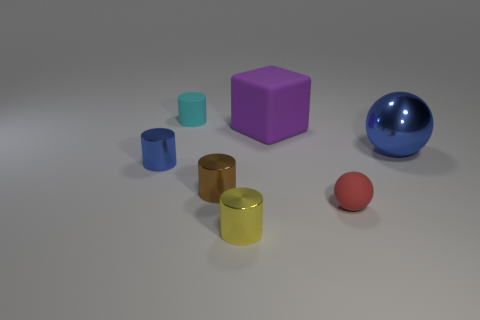Do the blue sphere to the right of the brown cylinder and the small cylinder behind the big rubber cube have the same material?
Your response must be concise. No. There is a shiny ball; is its color the same as the large thing that is left of the metal sphere?
Your answer should be very brief. No. There is a object that is both on the right side of the purple object and in front of the blue cylinder; what is its shape?
Give a very brief answer. Sphere. What number of tiny purple blocks are there?
Ensure brevity in your answer.  0. There is a shiny object that is the same color as the big metal ball; what is its shape?
Offer a terse response. Cylinder. What size is the other object that is the same shape as the red object?
Ensure brevity in your answer.  Large. There is a small rubber object that is on the right side of the brown shiny cylinder; is it the same shape as the big purple thing?
Your response must be concise. No. The metallic object right of the small red matte sphere is what color?
Provide a short and direct response. Blue. What number of other things are there of the same size as the cyan cylinder?
Your answer should be compact. 4. Is there anything else that is the same shape as the red rubber thing?
Your answer should be very brief. Yes. 